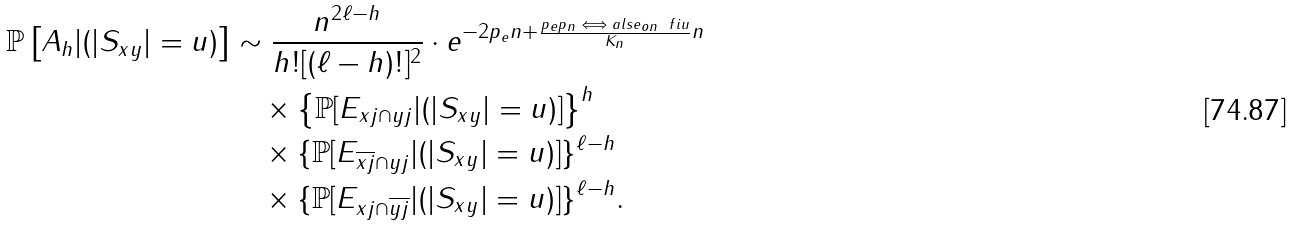Convert formula to latex. <formula><loc_0><loc_0><loc_500><loc_500>\mathbb { P } \left [ A _ { h } | ( | S _ { x y } | = u ) \right ] & \sim \frac { n ^ { 2 \ell - h } } { h ! [ ( \ell - h ) ! ] ^ { 2 } } \cdot e ^ { - 2 p _ { e } n + \frac { { p _ { e } p _ { n } \iff a l s e _ { o n } \ f i } u } { K _ { n } } n } \\ & \quad \times \left \{ \mathbb { P } [ E _ { { x } j \cap { y } j } | ( | S _ { x y } | = u ) ] \right \} ^ { h } \\ & \quad \times \{ \mathbb { P } [ E _ { \overline { { x } j } \cap { y } j } | ( | S _ { x y } | = u ) ] \} ^ { { \ell } - h } \\ & \quad \times \{ \mathbb { P } [ E _ { { x } j \cap { \overline { y j } } } | ( | S _ { x y } | = u ) ] \} ^ { { \ell } - h } .</formula> 